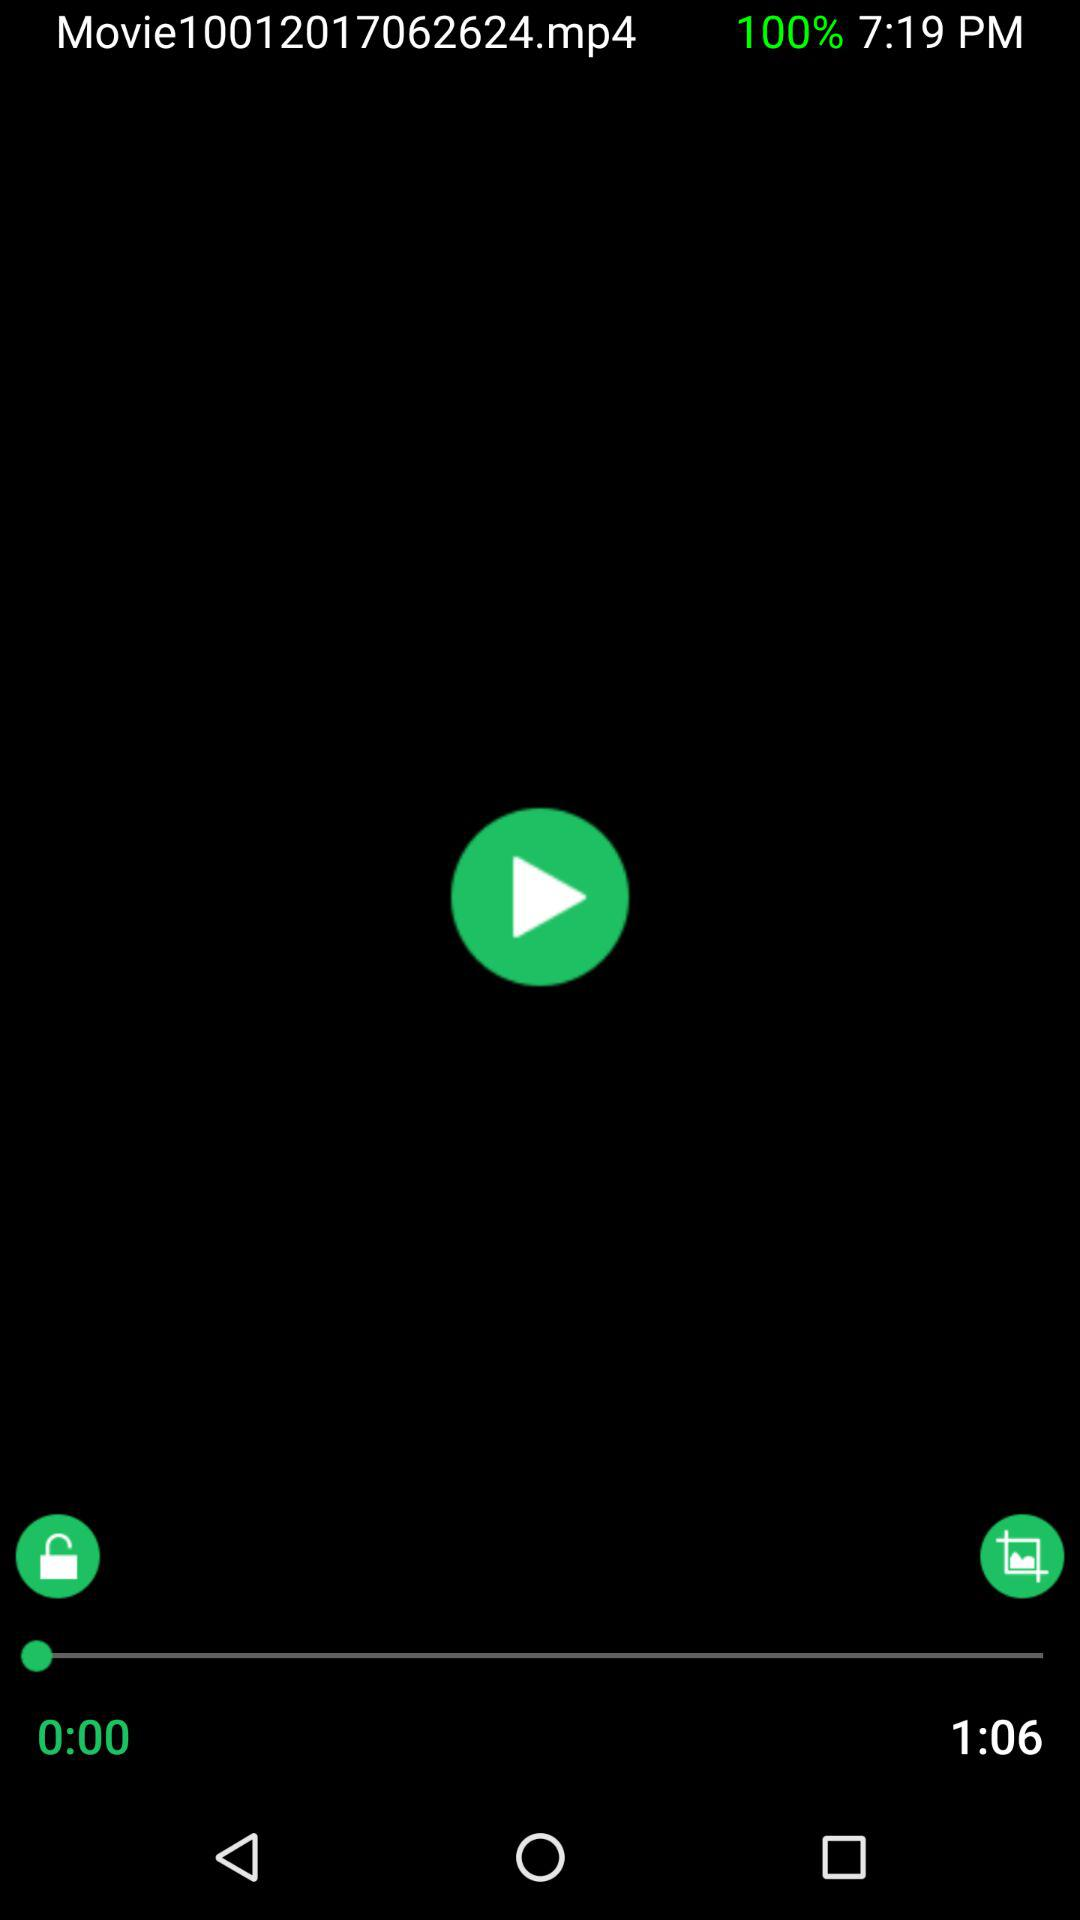What is the name of the video being played? The name of the video is "Movie10012017062624.mp4". 